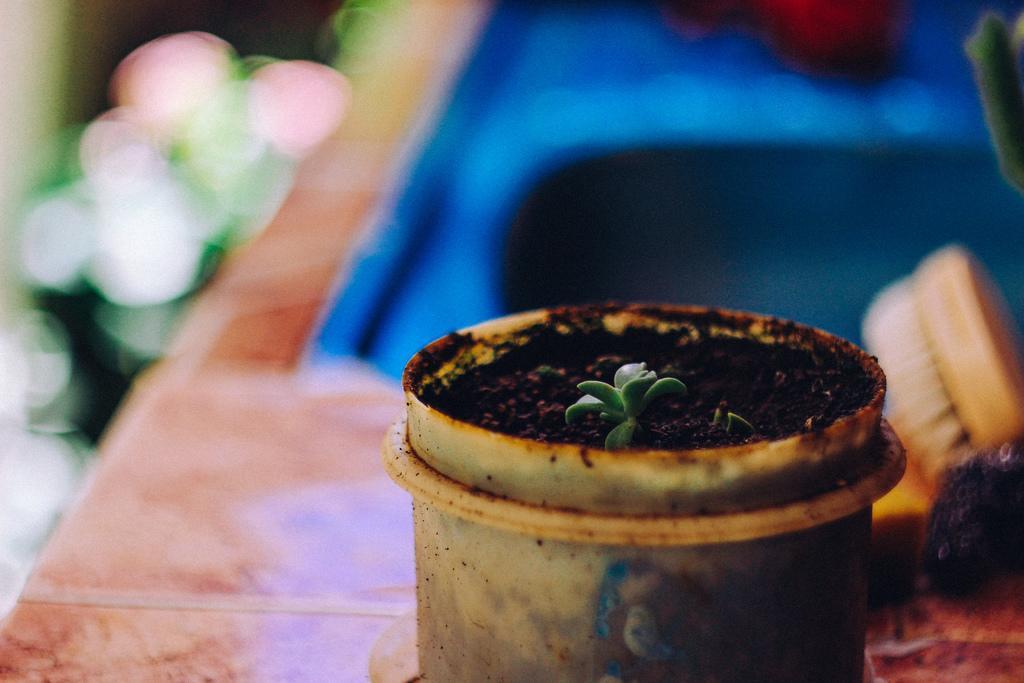In one or two sentences, can you explain what this image depicts? n the image in the center there is a table. On the table,we can see one plant pot,one plant and few other objects. 